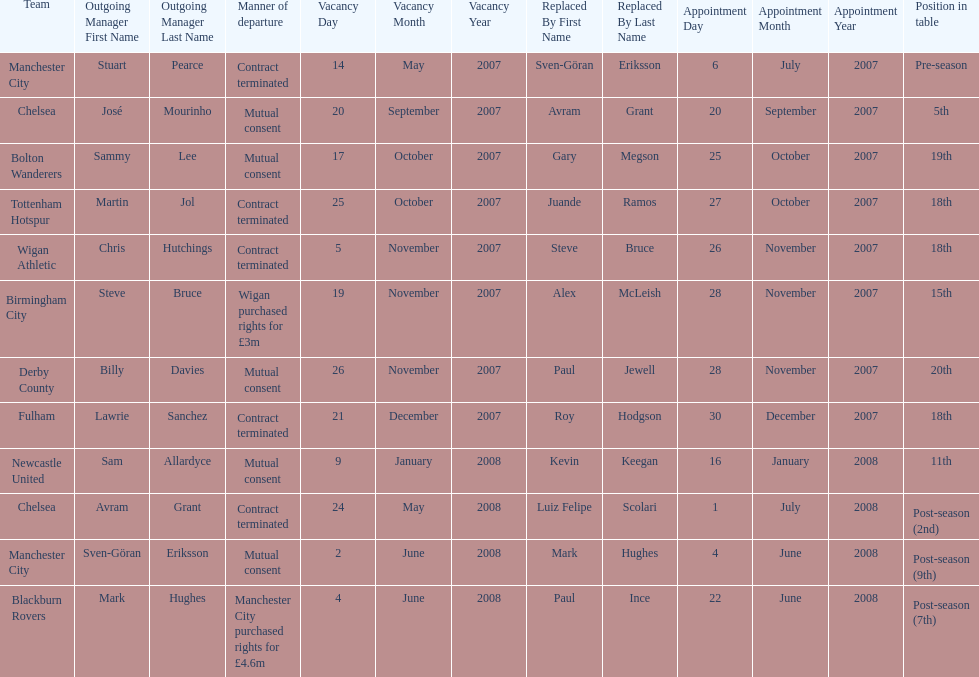How many outgoing managers were appointed in november 2007? 3. Parse the table in full. {'header': ['Team', 'Outgoing Manager First Name', 'Outgoing Manager Last Name', 'Manner of departure', 'Vacancy Day', 'Vacancy Month', 'Vacancy Year', 'Replaced By First Name', 'Replaced By Last Name', 'Appointment Day', 'Appointment Month', 'Appointment Year', 'Position in table'], 'rows': [['Manchester City', 'Stuart', 'Pearce', 'Contract terminated', '14', 'May', '2007', 'Sven-Göran', 'Eriksson', '6', 'July', '2007', 'Pre-season'], ['Chelsea', 'José', 'Mourinho', 'Mutual consent', '20', 'September', '2007', 'Avram', 'Grant', '20', 'September', '2007', '5th'], ['Bolton Wanderers', 'Sammy', 'Lee', 'Mutual consent', '17', 'October', '2007', 'Gary', 'Megson', '25', 'October', '2007', '19th'], ['Tottenham Hotspur', 'Martin', 'Jol', 'Contract terminated', '25', 'October', '2007', 'Juande', 'Ramos', '27', 'October', '2007', '18th'], ['Wigan Athletic', 'Chris', 'Hutchings', 'Contract terminated', '5', 'November', '2007', 'Steve', 'Bruce', '26', 'November', '2007', '18th'], ['Birmingham City', 'Steve', 'Bruce', 'Wigan purchased rights for £3m', '19', 'November', '2007', 'Alex', 'McLeish', '28', 'November', '2007', '15th'], ['Derby County', 'Billy', 'Davies', 'Mutual consent', '26', 'November', '2007', 'Paul', 'Jewell', '28', 'November', '2007', '20th'], ['Fulham', 'Lawrie', 'Sanchez', 'Contract terminated', '21', 'December', '2007', 'Roy', 'Hodgson', '30', 'December', '2007', '18th'], ['Newcastle United', 'Sam', 'Allardyce', 'Mutual consent', '9', 'January', '2008', 'Kevin', 'Keegan', '16', 'January', '2008', '11th'], ['Chelsea', 'Avram', 'Grant', 'Contract terminated', '24', 'May', '2008', 'Luiz Felipe', 'Scolari', '1', 'July', '2008', 'Post-season (2nd)'], ['Manchester City', 'Sven-Göran', 'Eriksson', 'Mutual consent', '2', 'June', '2008', 'Mark', 'Hughes', '4', 'June', '2008', 'Post-season (9th)'], ['Blackburn Rovers', 'Mark', 'Hughes', 'Manchester City purchased rights for £4.6m', '4', 'June', '2008', 'Paul', 'Ince', '22', 'June', '2008', 'Post-season (7th)']]} 